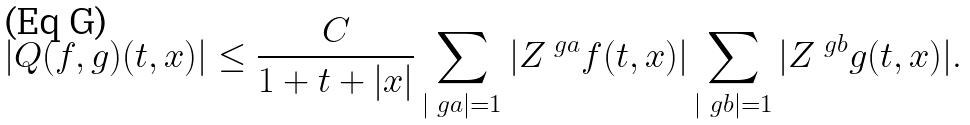Convert formula to latex. <formula><loc_0><loc_0><loc_500><loc_500>| Q ( f , g ) ( t , x ) | \leq \frac { C } { 1 + t + | x | } \sum _ { | \ g a | = 1 } | Z ^ { \ g a } f ( t , x ) | \sum _ { | \ g b | = 1 } | Z ^ { \ g b } g ( t , x ) | .</formula> 